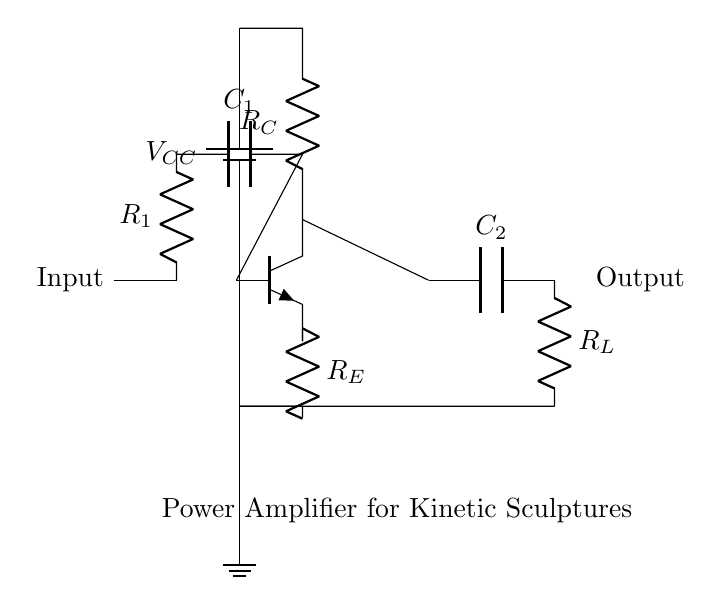What are the main components in the circuit? The main components are a battery, a resistor, a capacitor, and a transistor. These components are clearly labeled in the diagram, allowing for easy identification.
Answer: Battery, resistor, capacitor, transistor What is the function of the resistor labeled R1? R1 serves as an input resistor in the circuit, controlling the amount of current that flows into the input stage. It is typically used for biasing the transistor and protecting it from excessive current.
Answer: Input biasing How many capacitors are present in this circuit? There are two capacitors in the circuit, labeled C1 and C2. Both components are visually listed in the diagram and are positioned distinctly in the input and output stages, respectively.
Answer: Two What is connected to the output of the transistor? The output of the transistor is connected to a capacitor (C2), which then connects to a load resistor (R_L). This sequence is visible in the circuit path from the transistor collector to the output stage.
Answer: Capacitor and load resistor What does the resistor R_E do in this circuit? Resistor R_E is an emitter resistor, which helps stabilize the transistor's operating point by providing negative feedback. It is connected to the emitter and affects the overall gain of the amplifier.
Answer: Stabilizes operating point What is the voltage source in this circuit? The voltage source in this circuit is labeled V_CC, which represents the supply voltage for powering the amplifier. It is indicated at the top of the circuit diagram.
Answer: V_CC What type of amplifier is represented by this circuit? This circuit represents a power amplifier, specifically designed for driving large-scale kinetic sculptures, as noted in the label at the bottom of the diagram.
Answer: Power amplifier 